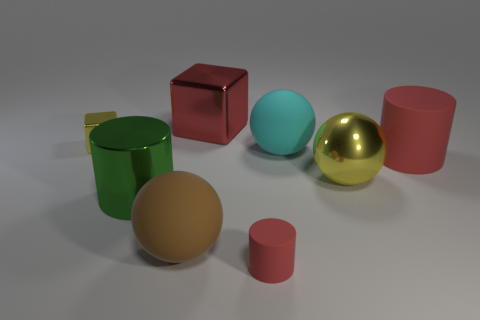Is there a green metal thing of the same shape as the red metallic thing?
Give a very brief answer. No. There is a big cyan thing; is its shape the same as the yellow shiny object right of the big brown thing?
Your answer should be very brief. Yes. How many cylinders are large objects or big yellow objects?
Your answer should be compact. 2. The yellow thing to the right of the big cube has what shape?
Your response must be concise. Sphere. How many large yellow things are the same material as the yellow block?
Offer a very short reply. 1. Are there fewer green metallic cylinders on the left side of the brown ball than shiny cylinders?
Your answer should be compact. No. What is the size of the yellow thing that is to the left of the red object in front of the metallic cylinder?
Keep it short and to the point. Small. There is a big shiny sphere; is it the same color as the tiny object that is behind the cyan matte thing?
Your response must be concise. Yes. There is a block that is the same size as the green metal thing; what is it made of?
Ensure brevity in your answer.  Metal. Is the number of cyan rubber spheres that are on the left side of the large metal cube less than the number of green metallic cylinders on the right side of the big green object?
Ensure brevity in your answer.  No. 